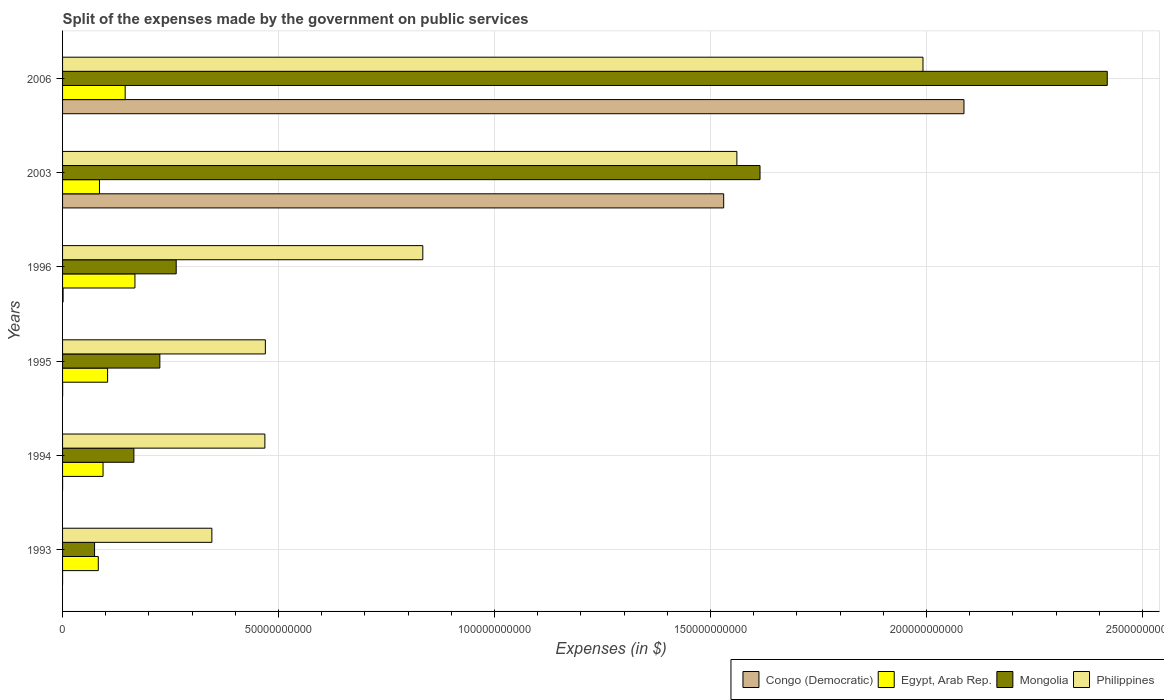Are the number of bars per tick equal to the number of legend labels?
Make the answer very short. Yes. How many bars are there on the 1st tick from the bottom?
Offer a terse response. 4. What is the expenses made by the government on public services in Mongolia in 2006?
Keep it short and to the point. 2.42e+11. Across all years, what is the maximum expenses made by the government on public services in Philippines?
Offer a terse response. 1.99e+11. Across all years, what is the minimum expenses made by the government on public services in Philippines?
Offer a terse response. 3.46e+1. In which year was the expenses made by the government on public services in Egypt, Arab Rep. minimum?
Your answer should be very brief. 1993. What is the total expenses made by the government on public services in Congo (Democratic) in the graph?
Make the answer very short. 3.62e+11. What is the difference between the expenses made by the government on public services in Congo (Democratic) in 1994 and that in 2003?
Ensure brevity in your answer.  -1.53e+11. What is the difference between the expenses made by the government on public services in Philippines in 1995 and the expenses made by the government on public services in Egypt, Arab Rep. in 2003?
Make the answer very short. 3.84e+1. What is the average expenses made by the government on public services in Egypt, Arab Rep. per year?
Give a very brief answer. 1.13e+1. In the year 2003, what is the difference between the expenses made by the government on public services in Philippines and expenses made by the government on public services in Egypt, Arab Rep.?
Ensure brevity in your answer.  1.48e+11. In how many years, is the expenses made by the government on public services in Mongolia greater than 80000000000 $?
Provide a succinct answer. 2. What is the ratio of the expenses made by the government on public services in Congo (Democratic) in 2003 to that in 2006?
Offer a very short reply. 0.73. Is the expenses made by the government on public services in Egypt, Arab Rep. in 1995 less than that in 2003?
Ensure brevity in your answer.  No. What is the difference between the highest and the second highest expenses made by the government on public services in Congo (Democratic)?
Your answer should be very brief. 5.56e+1. What is the difference between the highest and the lowest expenses made by the government on public services in Philippines?
Provide a short and direct response. 1.65e+11. In how many years, is the expenses made by the government on public services in Congo (Democratic) greater than the average expenses made by the government on public services in Congo (Democratic) taken over all years?
Your answer should be very brief. 2. Is the sum of the expenses made by the government on public services in Philippines in 1993 and 1994 greater than the maximum expenses made by the government on public services in Egypt, Arab Rep. across all years?
Your response must be concise. Yes. What does the 3rd bar from the bottom in 1994 represents?
Offer a very short reply. Mongolia. How many bars are there?
Offer a very short reply. 24. What is the difference between two consecutive major ticks on the X-axis?
Offer a very short reply. 5.00e+1. Are the values on the major ticks of X-axis written in scientific E-notation?
Your answer should be very brief. No. How many legend labels are there?
Provide a short and direct response. 4. How are the legend labels stacked?
Keep it short and to the point. Horizontal. What is the title of the graph?
Your answer should be compact. Split of the expenses made by the government on public services. What is the label or title of the X-axis?
Make the answer very short. Expenses (in $). What is the label or title of the Y-axis?
Give a very brief answer. Years. What is the Expenses (in $) of Congo (Democratic) in 1993?
Keep it short and to the point. 3.19e+04. What is the Expenses (in $) in Egypt, Arab Rep. in 1993?
Give a very brief answer. 8.27e+09. What is the Expenses (in $) in Mongolia in 1993?
Keep it short and to the point. 7.41e+09. What is the Expenses (in $) in Philippines in 1993?
Make the answer very short. 3.46e+1. What is the Expenses (in $) of Congo (Democratic) in 1994?
Your answer should be compact. 1.49e+06. What is the Expenses (in $) in Egypt, Arab Rep. in 1994?
Your response must be concise. 9.37e+09. What is the Expenses (in $) in Mongolia in 1994?
Your answer should be very brief. 1.65e+1. What is the Expenses (in $) in Philippines in 1994?
Provide a short and direct response. 4.68e+1. What is the Expenses (in $) in Congo (Democratic) in 1995?
Your answer should be compact. 1.21e+07. What is the Expenses (in $) of Egypt, Arab Rep. in 1995?
Give a very brief answer. 1.04e+1. What is the Expenses (in $) in Mongolia in 1995?
Provide a short and direct response. 2.25e+1. What is the Expenses (in $) in Philippines in 1995?
Provide a short and direct response. 4.70e+1. What is the Expenses (in $) of Congo (Democratic) in 1996?
Make the answer very short. 1.22e+08. What is the Expenses (in $) in Egypt, Arab Rep. in 1996?
Your response must be concise. 1.68e+1. What is the Expenses (in $) of Mongolia in 1996?
Offer a terse response. 2.63e+1. What is the Expenses (in $) in Philippines in 1996?
Provide a succinct answer. 8.34e+1. What is the Expenses (in $) in Congo (Democratic) in 2003?
Keep it short and to the point. 1.53e+11. What is the Expenses (in $) in Egypt, Arab Rep. in 2003?
Ensure brevity in your answer.  8.54e+09. What is the Expenses (in $) of Mongolia in 2003?
Give a very brief answer. 1.61e+11. What is the Expenses (in $) in Philippines in 2003?
Keep it short and to the point. 1.56e+11. What is the Expenses (in $) of Congo (Democratic) in 2006?
Provide a short and direct response. 2.09e+11. What is the Expenses (in $) in Egypt, Arab Rep. in 2006?
Your response must be concise. 1.45e+1. What is the Expenses (in $) of Mongolia in 2006?
Offer a very short reply. 2.42e+11. What is the Expenses (in $) of Philippines in 2006?
Your response must be concise. 1.99e+11. Across all years, what is the maximum Expenses (in $) of Congo (Democratic)?
Your response must be concise. 2.09e+11. Across all years, what is the maximum Expenses (in $) in Egypt, Arab Rep.?
Provide a succinct answer. 1.68e+1. Across all years, what is the maximum Expenses (in $) in Mongolia?
Offer a terse response. 2.42e+11. Across all years, what is the maximum Expenses (in $) in Philippines?
Offer a terse response. 1.99e+11. Across all years, what is the minimum Expenses (in $) in Congo (Democratic)?
Your answer should be compact. 3.19e+04. Across all years, what is the minimum Expenses (in $) of Egypt, Arab Rep.?
Offer a terse response. 8.27e+09. Across all years, what is the minimum Expenses (in $) of Mongolia?
Your answer should be very brief. 7.41e+09. Across all years, what is the minimum Expenses (in $) in Philippines?
Make the answer very short. 3.46e+1. What is the total Expenses (in $) of Congo (Democratic) in the graph?
Provide a succinct answer. 3.62e+11. What is the total Expenses (in $) of Egypt, Arab Rep. in the graph?
Ensure brevity in your answer.  6.79e+1. What is the total Expenses (in $) in Mongolia in the graph?
Your answer should be compact. 4.76e+11. What is the total Expenses (in $) in Philippines in the graph?
Your answer should be very brief. 5.67e+11. What is the difference between the Expenses (in $) in Congo (Democratic) in 1993 and that in 1994?
Offer a very short reply. -1.46e+06. What is the difference between the Expenses (in $) in Egypt, Arab Rep. in 1993 and that in 1994?
Your answer should be compact. -1.10e+09. What is the difference between the Expenses (in $) of Mongolia in 1993 and that in 1994?
Offer a very short reply. -9.11e+09. What is the difference between the Expenses (in $) in Philippines in 1993 and that in 1994?
Your response must be concise. -1.23e+1. What is the difference between the Expenses (in $) of Congo (Democratic) in 1993 and that in 1995?
Provide a short and direct response. -1.20e+07. What is the difference between the Expenses (in $) of Egypt, Arab Rep. in 1993 and that in 1995?
Ensure brevity in your answer.  -2.15e+09. What is the difference between the Expenses (in $) of Mongolia in 1993 and that in 1995?
Provide a succinct answer. -1.51e+1. What is the difference between the Expenses (in $) of Philippines in 1993 and that in 1995?
Ensure brevity in your answer.  -1.24e+1. What is the difference between the Expenses (in $) of Congo (Democratic) in 1993 and that in 1996?
Ensure brevity in your answer.  -1.22e+08. What is the difference between the Expenses (in $) in Egypt, Arab Rep. in 1993 and that in 1996?
Provide a succinct answer. -8.48e+09. What is the difference between the Expenses (in $) in Mongolia in 1993 and that in 1996?
Offer a very short reply. -1.89e+1. What is the difference between the Expenses (in $) in Philippines in 1993 and that in 1996?
Provide a succinct answer. -4.88e+1. What is the difference between the Expenses (in $) in Congo (Democratic) in 1993 and that in 2003?
Offer a terse response. -1.53e+11. What is the difference between the Expenses (in $) of Egypt, Arab Rep. in 1993 and that in 2003?
Provide a short and direct response. -2.70e+08. What is the difference between the Expenses (in $) of Mongolia in 1993 and that in 2003?
Your response must be concise. -1.54e+11. What is the difference between the Expenses (in $) in Philippines in 1993 and that in 2003?
Your response must be concise. -1.22e+11. What is the difference between the Expenses (in $) of Congo (Democratic) in 1993 and that in 2006?
Offer a very short reply. -2.09e+11. What is the difference between the Expenses (in $) of Egypt, Arab Rep. in 1993 and that in 2006?
Keep it short and to the point. -6.22e+09. What is the difference between the Expenses (in $) of Mongolia in 1993 and that in 2006?
Your response must be concise. -2.34e+11. What is the difference between the Expenses (in $) of Philippines in 1993 and that in 2006?
Offer a terse response. -1.65e+11. What is the difference between the Expenses (in $) in Congo (Democratic) in 1994 and that in 1995?
Provide a short and direct response. -1.06e+07. What is the difference between the Expenses (in $) in Egypt, Arab Rep. in 1994 and that in 1995?
Your answer should be compact. -1.05e+09. What is the difference between the Expenses (in $) in Mongolia in 1994 and that in 1995?
Offer a very short reply. -6.00e+09. What is the difference between the Expenses (in $) of Philippines in 1994 and that in 1995?
Offer a very short reply. -1.13e+08. What is the difference between the Expenses (in $) in Congo (Democratic) in 1994 and that in 1996?
Provide a succinct answer. -1.21e+08. What is the difference between the Expenses (in $) of Egypt, Arab Rep. in 1994 and that in 1996?
Give a very brief answer. -7.38e+09. What is the difference between the Expenses (in $) in Mongolia in 1994 and that in 1996?
Ensure brevity in your answer.  -9.80e+09. What is the difference between the Expenses (in $) of Philippines in 1994 and that in 1996?
Provide a short and direct response. -3.66e+1. What is the difference between the Expenses (in $) in Congo (Democratic) in 1994 and that in 2003?
Give a very brief answer. -1.53e+11. What is the difference between the Expenses (in $) in Egypt, Arab Rep. in 1994 and that in 2003?
Keep it short and to the point. 8.29e+08. What is the difference between the Expenses (in $) of Mongolia in 1994 and that in 2003?
Keep it short and to the point. -1.45e+11. What is the difference between the Expenses (in $) in Philippines in 1994 and that in 2003?
Your response must be concise. -1.09e+11. What is the difference between the Expenses (in $) of Congo (Democratic) in 1994 and that in 2006?
Provide a succinct answer. -2.09e+11. What is the difference between the Expenses (in $) of Egypt, Arab Rep. in 1994 and that in 2006?
Provide a short and direct response. -5.12e+09. What is the difference between the Expenses (in $) in Mongolia in 1994 and that in 2006?
Your answer should be very brief. -2.25e+11. What is the difference between the Expenses (in $) in Philippines in 1994 and that in 2006?
Your response must be concise. -1.52e+11. What is the difference between the Expenses (in $) of Congo (Democratic) in 1995 and that in 1996?
Make the answer very short. -1.10e+08. What is the difference between the Expenses (in $) in Egypt, Arab Rep. in 1995 and that in 1996?
Your answer should be very brief. -6.33e+09. What is the difference between the Expenses (in $) in Mongolia in 1995 and that in 1996?
Your response must be concise. -3.79e+09. What is the difference between the Expenses (in $) in Philippines in 1995 and that in 1996?
Offer a terse response. -3.65e+1. What is the difference between the Expenses (in $) of Congo (Democratic) in 1995 and that in 2003?
Provide a short and direct response. -1.53e+11. What is the difference between the Expenses (in $) of Egypt, Arab Rep. in 1995 and that in 2003?
Your answer should be compact. 1.88e+09. What is the difference between the Expenses (in $) in Mongolia in 1995 and that in 2003?
Make the answer very short. -1.39e+11. What is the difference between the Expenses (in $) in Philippines in 1995 and that in 2003?
Ensure brevity in your answer.  -1.09e+11. What is the difference between the Expenses (in $) of Congo (Democratic) in 1995 and that in 2006?
Provide a succinct answer. -2.09e+11. What is the difference between the Expenses (in $) in Egypt, Arab Rep. in 1995 and that in 2006?
Make the answer very short. -4.07e+09. What is the difference between the Expenses (in $) in Mongolia in 1995 and that in 2006?
Give a very brief answer. -2.19e+11. What is the difference between the Expenses (in $) of Philippines in 1995 and that in 2006?
Keep it short and to the point. -1.52e+11. What is the difference between the Expenses (in $) of Congo (Democratic) in 1996 and that in 2003?
Your answer should be very brief. -1.53e+11. What is the difference between the Expenses (in $) of Egypt, Arab Rep. in 1996 and that in 2003?
Make the answer very short. 8.21e+09. What is the difference between the Expenses (in $) in Mongolia in 1996 and that in 2003?
Offer a very short reply. -1.35e+11. What is the difference between the Expenses (in $) of Philippines in 1996 and that in 2003?
Provide a succinct answer. -7.27e+1. What is the difference between the Expenses (in $) of Congo (Democratic) in 1996 and that in 2006?
Keep it short and to the point. -2.09e+11. What is the difference between the Expenses (in $) of Egypt, Arab Rep. in 1996 and that in 2006?
Provide a succinct answer. 2.26e+09. What is the difference between the Expenses (in $) of Mongolia in 1996 and that in 2006?
Make the answer very short. -2.16e+11. What is the difference between the Expenses (in $) in Philippines in 1996 and that in 2006?
Keep it short and to the point. -1.16e+11. What is the difference between the Expenses (in $) in Congo (Democratic) in 2003 and that in 2006?
Keep it short and to the point. -5.56e+1. What is the difference between the Expenses (in $) in Egypt, Arab Rep. in 2003 and that in 2006?
Your response must be concise. -5.95e+09. What is the difference between the Expenses (in $) in Mongolia in 2003 and that in 2006?
Provide a succinct answer. -8.04e+1. What is the difference between the Expenses (in $) of Philippines in 2003 and that in 2006?
Provide a succinct answer. -4.31e+1. What is the difference between the Expenses (in $) of Congo (Democratic) in 1993 and the Expenses (in $) of Egypt, Arab Rep. in 1994?
Offer a terse response. -9.37e+09. What is the difference between the Expenses (in $) in Congo (Democratic) in 1993 and the Expenses (in $) in Mongolia in 1994?
Make the answer very short. -1.65e+1. What is the difference between the Expenses (in $) of Congo (Democratic) in 1993 and the Expenses (in $) of Philippines in 1994?
Keep it short and to the point. -4.68e+1. What is the difference between the Expenses (in $) in Egypt, Arab Rep. in 1993 and the Expenses (in $) in Mongolia in 1994?
Your response must be concise. -8.24e+09. What is the difference between the Expenses (in $) of Egypt, Arab Rep. in 1993 and the Expenses (in $) of Philippines in 1994?
Give a very brief answer. -3.86e+1. What is the difference between the Expenses (in $) in Mongolia in 1993 and the Expenses (in $) in Philippines in 1994?
Offer a very short reply. -3.94e+1. What is the difference between the Expenses (in $) in Congo (Democratic) in 1993 and the Expenses (in $) in Egypt, Arab Rep. in 1995?
Offer a very short reply. -1.04e+1. What is the difference between the Expenses (in $) in Congo (Democratic) in 1993 and the Expenses (in $) in Mongolia in 1995?
Your answer should be compact. -2.25e+1. What is the difference between the Expenses (in $) of Congo (Democratic) in 1993 and the Expenses (in $) of Philippines in 1995?
Offer a very short reply. -4.69e+1. What is the difference between the Expenses (in $) of Egypt, Arab Rep. in 1993 and the Expenses (in $) of Mongolia in 1995?
Your response must be concise. -1.42e+1. What is the difference between the Expenses (in $) in Egypt, Arab Rep. in 1993 and the Expenses (in $) in Philippines in 1995?
Your response must be concise. -3.87e+1. What is the difference between the Expenses (in $) in Mongolia in 1993 and the Expenses (in $) in Philippines in 1995?
Provide a short and direct response. -3.95e+1. What is the difference between the Expenses (in $) of Congo (Democratic) in 1993 and the Expenses (in $) of Egypt, Arab Rep. in 1996?
Offer a terse response. -1.68e+1. What is the difference between the Expenses (in $) of Congo (Democratic) in 1993 and the Expenses (in $) of Mongolia in 1996?
Provide a succinct answer. -2.63e+1. What is the difference between the Expenses (in $) in Congo (Democratic) in 1993 and the Expenses (in $) in Philippines in 1996?
Ensure brevity in your answer.  -8.34e+1. What is the difference between the Expenses (in $) of Egypt, Arab Rep. in 1993 and the Expenses (in $) of Mongolia in 1996?
Your answer should be compact. -1.80e+1. What is the difference between the Expenses (in $) of Egypt, Arab Rep. in 1993 and the Expenses (in $) of Philippines in 1996?
Provide a succinct answer. -7.51e+1. What is the difference between the Expenses (in $) of Mongolia in 1993 and the Expenses (in $) of Philippines in 1996?
Offer a very short reply. -7.60e+1. What is the difference between the Expenses (in $) of Congo (Democratic) in 1993 and the Expenses (in $) of Egypt, Arab Rep. in 2003?
Give a very brief answer. -8.54e+09. What is the difference between the Expenses (in $) of Congo (Democratic) in 1993 and the Expenses (in $) of Mongolia in 2003?
Your answer should be compact. -1.61e+11. What is the difference between the Expenses (in $) in Congo (Democratic) in 1993 and the Expenses (in $) in Philippines in 2003?
Your answer should be compact. -1.56e+11. What is the difference between the Expenses (in $) of Egypt, Arab Rep. in 1993 and the Expenses (in $) of Mongolia in 2003?
Give a very brief answer. -1.53e+11. What is the difference between the Expenses (in $) in Egypt, Arab Rep. in 1993 and the Expenses (in $) in Philippines in 2003?
Ensure brevity in your answer.  -1.48e+11. What is the difference between the Expenses (in $) of Mongolia in 1993 and the Expenses (in $) of Philippines in 2003?
Provide a succinct answer. -1.49e+11. What is the difference between the Expenses (in $) in Congo (Democratic) in 1993 and the Expenses (in $) in Egypt, Arab Rep. in 2006?
Provide a short and direct response. -1.45e+1. What is the difference between the Expenses (in $) of Congo (Democratic) in 1993 and the Expenses (in $) of Mongolia in 2006?
Make the answer very short. -2.42e+11. What is the difference between the Expenses (in $) in Congo (Democratic) in 1993 and the Expenses (in $) in Philippines in 2006?
Your answer should be compact. -1.99e+11. What is the difference between the Expenses (in $) in Egypt, Arab Rep. in 1993 and the Expenses (in $) in Mongolia in 2006?
Your answer should be compact. -2.34e+11. What is the difference between the Expenses (in $) in Egypt, Arab Rep. in 1993 and the Expenses (in $) in Philippines in 2006?
Your response must be concise. -1.91e+11. What is the difference between the Expenses (in $) of Mongolia in 1993 and the Expenses (in $) of Philippines in 2006?
Your response must be concise. -1.92e+11. What is the difference between the Expenses (in $) in Congo (Democratic) in 1994 and the Expenses (in $) in Egypt, Arab Rep. in 1995?
Keep it short and to the point. -1.04e+1. What is the difference between the Expenses (in $) in Congo (Democratic) in 1994 and the Expenses (in $) in Mongolia in 1995?
Offer a terse response. -2.25e+1. What is the difference between the Expenses (in $) in Congo (Democratic) in 1994 and the Expenses (in $) in Philippines in 1995?
Provide a succinct answer. -4.69e+1. What is the difference between the Expenses (in $) of Egypt, Arab Rep. in 1994 and the Expenses (in $) of Mongolia in 1995?
Offer a very short reply. -1.31e+1. What is the difference between the Expenses (in $) of Egypt, Arab Rep. in 1994 and the Expenses (in $) of Philippines in 1995?
Your answer should be compact. -3.76e+1. What is the difference between the Expenses (in $) of Mongolia in 1994 and the Expenses (in $) of Philippines in 1995?
Make the answer very short. -3.04e+1. What is the difference between the Expenses (in $) of Congo (Democratic) in 1994 and the Expenses (in $) of Egypt, Arab Rep. in 1996?
Give a very brief answer. -1.68e+1. What is the difference between the Expenses (in $) of Congo (Democratic) in 1994 and the Expenses (in $) of Mongolia in 1996?
Ensure brevity in your answer.  -2.63e+1. What is the difference between the Expenses (in $) of Congo (Democratic) in 1994 and the Expenses (in $) of Philippines in 1996?
Offer a very short reply. -8.34e+1. What is the difference between the Expenses (in $) of Egypt, Arab Rep. in 1994 and the Expenses (in $) of Mongolia in 1996?
Your response must be concise. -1.69e+1. What is the difference between the Expenses (in $) of Egypt, Arab Rep. in 1994 and the Expenses (in $) of Philippines in 1996?
Make the answer very short. -7.40e+1. What is the difference between the Expenses (in $) of Mongolia in 1994 and the Expenses (in $) of Philippines in 1996?
Make the answer very short. -6.69e+1. What is the difference between the Expenses (in $) in Congo (Democratic) in 1994 and the Expenses (in $) in Egypt, Arab Rep. in 2003?
Make the answer very short. -8.54e+09. What is the difference between the Expenses (in $) in Congo (Democratic) in 1994 and the Expenses (in $) in Mongolia in 2003?
Provide a short and direct response. -1.61e+11. What is the difference between the Expenses (in $) of Congo (Democratic) in 1994 and the Expenses (in $) of Philippines in 2003?
Provide a short and direct response. -1.56e+11. What is the difference between the Expenses (in $) of Egypt, Arab Rep. in 1994 and the Expenses (in $) of Mongolia in 2003?
Your response must be concise. -1.52e+11. What is the difference between the Expenses (in $) of Egypt, Arab Rep. in 1994 and the Expenses (in $) of Philippines in 2003?
Your answer should be very brief. -1.47e+11. What is the difference between the Expenses (in $) of Mongolia in 1994 and the Expenses (in $) of Philippines in 2003?
Keep it short and to the point. -1.40e+11. What is the difference between the Expenses (in $) in Congo (Democratic) in 1994 and the Expenses (in $) in Egypt, Arab Rep. in 2006?
Keep it short and to the point. -1.45e+1. What is the difference between the Expenses (in $) in Congo (Democratic) in 1994 and the Expenses (in $) in Mongolia in 2006?
Your answer should be very brief. -2.42e+11. What is the difference between the Expenses (in $) of Congo (Democratic) in 1994 and the Expenses (in $) of Philippines in 2006?
Your answer should be compact. -1.99e+11. What is the difference between the Expenses (in $) of Egypt, Arab Rep. in 1994 and the Expenses (in $) of Mongolia in 2006?
Make the answer very short. -2.32e+11. What is the difference between the Expenses (in $) of Egypt, Arab Rep. in 1994 and the Expenses (in $) of Philippines in 2006?
Provide a succinct answer. -1.90e+11. What is the difference between the Expenses (in $) in Mongolia in 1994 and the Expenses (in $) in Philippines in 2006?
Provide a short and direct response. -1.83e+11. What is the difference between the Expenses (in $) in Congo (Democratic) in 1995 and the Expenses (in $) in Egypt, Arab Rep. in 1996?
Keep it short and to the point. -1.67e+1. What is the difference between the Expenses (in $) in Congo (Democratic) in 1995 and the Expenses (in $) in Mongolia in 1996?
Make the answer very short. -2.63e+1. What is the difference between the Expenses (in $) of Congo (Democratic) in 1995 and the Expenses (in $) of Philippines in 1996?
Provide a succinct answer. -8.34e+1. What is the difference between the Expenses (in $) of Egypt, Arab Rep. in 1995 and the Expenses (in $) of Mongolia in 1996?
Give a very brief answer. -1.59e+1. What is the difference between the Expenses (in $) in Egypt, Arab Rep. in 1995 and the Expenses (in $) in Philippines in 1996?
Give a very brief answer. -7.30e+1. What is the difference between the Expenses (in $) in Mongolia in 1995 and the Expenses (in $) in Philippines in 1996?
Your answer should be compact. -6.09e+1. What is the difference between the Expenses (in $) of Congo (Democratic) in 1995 and the Expenses (in $) of Egypt, Arab Rep. in 2003?
Provide a short and direct response. -8.53e+09. What is the difference between the Expenses (in $) of Congo (Democratic) in 1995 and the Expenses (in $) of Mongolia in 2003?
Keep it short and to the point. -1.61e+11. What is the difference between the Expenses (in $) of Congo (Democratic) in 1995 and the Expenses (in $) of Philippines in 2003?
Your answer should be compact. -1.56e+11. What is the difference between the Expenses (in $) of Egypt, Arab Rep. in 1995 and the Expenses (in $) of Mongolia in 2003?
Your response must be concise. -1.51e+11. What is the difference between the Expenses (in $) of Egypt, Arab Rep. in 1995 and the Expenses (in $) of Philippines in 2003?
Provide a succinct answer. -1.46e+11. What is the difference between the Expenses (in $) in Mongolia in 1995 and the Expenses (in $) in Philippines in 2003?
Offer a terse response. -1.34e+11. What is the difference between the Expenses (in $) in Congo (Democratic) in 1995 and the Expenses (in $) in Egypt, Arab Rep. in 2006?
Offer a terse response. -1.45e+1. What is the difference between the Expenses (in $) in Congo (Democratic) in 1995 and the Expenses (in $) in Mongolia in 2006?
Your answer should be compact. -2.42e+11. What is the difference between the Expenses (in $) of Congo (Democratic) in 1995 and the Expenses (in $) of Philippines in 2006?
Provide a succinct answer. -1.99e+11. What is the difference between the Expenses (in $) of Egypt, Arab Rep. in 1995 and the Expenses (in $) of Mongolia in 2006?
Provide a short and direct response. -2.31e+11. What is the difference between the Expenses (in $) in Egypt, Arab Rep. in 1995 and the Expenses (in $) in Philippines in 2006?
Ensure brevity in your answer.  -1.89e+11. What is the difference between the Expenses (in $) of Mongolia in 1995 and the Expenses (in $) of Philippines in 2006?
Ensure brevity in your answer.  -1.77e+11. What is the difference between the Expenses (in $) of Congo (Democratic) in 1996 and the Expenses (in $) of Egypt, Arab Rep. in 2003?
Your answer should be compact. -8.42e+09. What is the difference between the Expenses (in $) of Congo (Democratic) in 1996 and the Expenses (in $) of Mongolia in 2003?
Ensure brevity in your answer.  -1.61e+11. What is the difference between the Expenses (in $) of Congo (Democratic) in 1996 and the Expenses (in $) of Philippines in 2003?
Give a very brief answer. -1.56e+11. What is the difference between the Expenses (in $) of Egypt, Arab Rep. in 1996 and the Expenses (in $) of Mongolia in 2003?
Keep it short and to the point. -1.45e+11. What is the difference between the Expenses (in $) of Egypt, Arab Rep. in 1996 and the Expenses (in $) of Philippines in 2003?
Your answer should be compact. -1.39e+11. What is the difference between the Expenses (in $) in Mongolia in 1996 and the Expenses (in $) in Philippines in 2003?
Provide a succinct answer. -1.30e+11. What is the difference between the Expenses (in $) in Congo (Democratic) in 1996 and the Expenses (in $) in Egypt, Arab Rep. in 2006?
Offer a terse response. -1.44e+1. What is the difference between the Expenses (in $) in Congo (Democratic) in 1996 and the Expenses (in $) in Mongolia in 2006?
Provide a short and direct response. -2.42e+11. What is the difference between the Expenses (in $) of Congo (Democratic) in 1996 and the Expenses (in $) of Philippines in 2006?
Make the answer very short. -1.99e+11. What is the difference between the Expenses (in $) of Egypt, Arab Rep. in 1996 and the Expenses (in $) of Mongolia in 2006?
Your answer should be very brief. -2.25e+11. What is the difference between the Expenses (in $) in Egypt, Arab Rep. in 1996 and the Expenses (in $) in Philippines in 2006?
Provide a succinct answer. -1.82e+11. What is the difference between the Expenses (in $) of Mongolia in 1996 and the Expenses (in $) of Philippines in 2006?
Provide a short and direct response. -1.73e+11. What is the difference between the Expenses (in $) in Congo (Democratic) in 2003 and the Expenses (in $) in Egypt, Arab Rep. in 2006?
Your answer should be very brief. 1.39e+11. What is the difference between the Expenses (in $) of Congo (Democratic) in 2003 and the Expenses (in $) of Mongolia in 2006?
Keep it short and to the point. -8.88e+1. What is the difference between the Expenses (in $) of Congo (Democratic) in 2003 and the Expenses (in $) of Philippines in 2006?
Provide a short and direct response. -4.61e+1. What is the difference between the Expenses (in $) of Egypt, Arab Rep. in 2003 and the Expenses (in $) of Mongolia in 2006?
Offer a terse response. -2.33e+11. What is the difference between the Expenses (in $) in Egypt, Arab Rep. in 2003 and the Expenses (in $) in Philippines in 2006?
Your response must be concise. -1.91e+11. What is the difference between the Expenses (in $) in Mongolia in 2003 and the Expenses (in $) in Philippines in 2006?
Offer a terse response. -3.77e+1. What is the average Expenses (in $) in Congo (Democratic) per year?
Provide a short and direct response. 6.03e+1. What is the average Expenses (in $) in Egypt, Arab Rep. per year?
Your answer should be compact. 1.13e+1. What is the average Expenses (in $) of Mongolia per year?
Make the answer very short. 7.93e+1. What is the average Expenses (in $) in Philippines per year?
Provide a succinct answer. 9.45e+1. In the year 1993, what is the difference between the Expenses (in $) in Congo (Democratic) and Expenses (in $) in Egypt, Arab Rep.?
Provide a succinct answer. -8.27e+09. In the year 1993, what is the difference between the Expenses (in $) of Congo (Democratic) and Expenses (in $) of Mongolia?
Your answer should be compact. -7.41e+09. In the year 1993, what is the difference between the Expenses (in $) of Congo (Democratic) and Expenses (in $) of Philippines?
Offer a terse response. -3.46e+1. In the year 1993, what is the difference between the Expenses (in $) of Egypt, Arab Rep. and Expenses (in $) of Mongolia?
Make the answer very short. 8.65e+08. In the year 1993, what is the difference between the Expenses (in $) of Egypt, Arab Rep. and Expenses (in $) of Philippines?
Ensure brevity in your answer.  -2.63e+1. In the year 1993, what is the difference between the Expenses (in $) of Mongolia and Expenses (in $) of Philippines?
Ensure brevity in your answer.  -2.72e+1. In the year 1994, what is the difference between the Expenses (in $) in Congo (Democratic) and Expenses (in $) in Egypt, Arab Rep.?
Provide a short and direct response. -9.37e+09. In the year 1994, what is the difference between the Expenses (in $) of Congo (Democratic) and Expenses (in $) of Mongolia?
Ensure brevity in your answer.  -1.65e+1. In the year 1994, what is the difference between the Expenses (in $) in Congo (Democratic) and Expenses (in $) in Philippines?
Give a very brief answer. -4.68e+1. In the year 1994, what is the difference between the Expenses (in $) of Egypt, Arab Rep. and Expenses (in $) of Mongolia?
Offer a very short reply. -7.14e+09. In the year 1994, what is the difference between the Expenses (in $) of Egypt, Arab Rep. and Expenses (in $) of Philippines?
Make the answer very short. -3.75e+1. In the year 1994, what is the difference between the Expenses (in $) in Mongolia and Expenses (in $) in Philippines?
Offer a very short reply. -3.03e+1. In the year 1995, what is the difference between the Expenses (in $) of Congo (Democratic) and Expenses (in $) of Egypt, Arab Rep.?
Ensure brevity in your answer.  -1.04e+1. In the year 1995, what is the difference between the Expenses (in $) in Congo (Democratic) and Expenses (in $) in Mongolia?
Make the answer very short. -2.25e+1. In the year 1995, what is the difference between the Expenses (in $) in Congo (Democratic) and Expenses (in $) in Philippines?
Provide a short and direct response. -4.69e+1. In the year 1995, what is the difference between the Expenses (in $) in Egypt, Arab Rep. and Expenses (in $) in Mongolia?
Make the answer very short. -1.21e+1. In the year 1995, what is the difference between the Expenses (in $) of Egypt, Arab Rep. and Expenses (in $) of Philippines?
Provide a short and direct response. -3.65e+1. In the year 1995, what is the difference between the Expenses (in $) in Mongolia and Expenses (in $) in Philippines?
Provide a short and direct response. -2.44e+1. In the year 1996, what is the difference between the Expenses (in $) in Congo (Democratic) and Expenses (in $) in Egypt, Arab Rep.?
Provide a short and direct response. -1.66e+1. In the year 1996, what is the difference between the Expenses (in $) in Congo (Democratic) and Expenses (in $) in Mongolia?
Provide a short and direct response. -2.62e+1. In the year 1996, what is the difference between the Expenses (in $) of Congo (Democratic) and Expenses (in $) of Philippines?
Your answer should be compact. -8.33e+1. In the year 1996, what is the difference between the Expenses (in $) in Egypt, Arab Rep. and Expenses (in $) in Mongolia?
Your response must be concise. -9.55e+09. In the year 1996, what is the difference between the Expenses (in $) of Egypt, Arab Rep. and Expenses (in $) of Philippines?
Provide a succinct answer. -6.66e+1. In the year 1996, what is the difference between the Expenses (in $) of Mongolia and Expenses (in $) of Philippines?
Your answer should be compact. -5.71e+1. In the year 2003, what is the difference between the Expenses (in $) in Congo (Democratic) and Expenses (in $) in Egypt, Arab Rep.?
Provide a short and direct response. 1.45e+11. In the year 2003, what is the difference between the Expenses (in $) of Congo (Democratic) and Expenses (in $) of Mongolia?
Ensure brevity in your answer.  -8.41e+09. In the year 2003, what is the difference between the Expenses (in $) of Congo (Democratic) and Expenses (in $) of Philippines?
Offer a very short reply. -3.05e+09. In the year 2003, what is the difference between the Expenses (in $) in Egypt, Arab Rep. and Expenses (in $) in Mongolia?
Give a very brief answer. -1.53e+11. In the year 2003, what is the difference between the Expenses (in $) of Egypt, Arab Rep. and Expenses (in $) of Philippines?
Your answer should be compact. -1.48e+11. In the year 2003, what is the difference between the Expenses (in $) of Mongolia and Expenses (in $) of Philippines?
Offer a very short reply. 5.36e+09. In the year 2006, what is the difference between the Expenses (in $) of Congo (Democratic) and Expenses (in $) of Egypt, Arab Rep.?
Offer a terse response. 1.94e+11. In the year 2006, what is the difference between the Expenses (in $) of Congo (Democratic) and Expenses (in $) of Mongolia?
Your answer should be compact. -3.32e+1. In the year 2006, what is the difference between the Expenses (in $) in Congo (Democratic) and Expenses (in $) in Philippines?
Your answer should be compact. 9.49e+09. In the year 2006, what is the difference between the Expenses (in $) of Egypt, Arab Rep. and Expenses (in $) of Mongolia?
Offer a very short reply. -2.27e+11. In the year 2006, what is the difference between the Expenses (in $) in Egypt, Arab Rep. and Expenses (in $) in Philippines?
Give a very brief answer. -1.85e+11. In the year 2006, what is the difference between the Expenses (in $) in Mongolia and Expenses (in $) in Philippines?
Give a very brief answer. 4.27e+1. What is the ratio of the Expenses (in $) in Congo (Democratic) in 1993 to that in 1994?
Provide a short and direct response. 0.02. What is the ratio of the Expenses (in $) of Egypt, Arab Rep. in 1993 to that in 1994?
Give a very brief answer. 0.88. What is the ratio of the Expenses (in $) in Mongolia in 1993 to that in 1994?
Provide a succinct answer. 0.45. What is the ratio of the Expenses (in $) of Philippines in 1993 to that in 1994?
Offer a terse response. 0.74. What is the ratio of the Expenses (in $) of Congo (Democratic) in 1993 to that in 1995?
Make the answer very short. 0. What is the ratio of the Expenses (in $) in Egypt, Arab Rep. in 1993 to that in 1995?
Your answer should be very brief. 0.79. What is the ratio of the Expenses (in $) in Mongolia in 1993 to that in 1995?
Provide a short and direct response. 0.33. What is the ratio of the Expenses (in $) in Philippines in 1993 to that in 1995?
Offer a very short reply. 0.74. What is the ratio of the Expenses (in $) of Egypt, Arab Rep. in 1993 to that in 1996?
Make the answer very short. 0.49. What is the ratio of the Expenses (in $) in Mongolia in 1993 to that in 1996?
Provide a short and direct response. 0.28. What is the ratio of the Expenses (in $) of Philippines in 1993 to that in 1996?
Ensure brevity in your answer.  0.41. What is the ratio of the Expenses (in $) in Egypt, Arab Rep. in 1993 to that in 2003?
Offer a very short reply. 0.97. What is the ratio of the Expenses (in $) in Mongolia in 1993 to that in 2003?
Offer a very short reply. 0.05. What is the ratio of the Expenses (in $) in Philippines in 1993 to that in 2003?
Provide a short and direct response. 0.22. What is the ratio of the Expenses (in $) in Egypt, Arab Rep. in 1993 to that in 2006?
Offer a terse response. 0.57. What is the ratio of the Expenses (in $) of Mongolia in 1993 to that in 2006?
Your answer should be compact. 0.03. What is the ratio of the Expenses (in $) in Philippines in 1993 to that in 2006?
Provide a succinct answer. 0.17. What is the ratio of the Expenses (in $) in Congo (Democratic) in 1994 to that in 1995?
Offer a very short reply. 0.12. What is the ratio of the Expenses (in $) in Egypt, Arab Rep. in 1994 to that in 1995?
Make the answer very short. 0.9. What is the ratio of the Expenses (in $) of Mongolia in 1994 to that in 1995?
Your answer should be very brief. 0.73. What is the ratio of the Expenses (in $) of Philippines in 1994 to that in 1995?
Give a very brief answer. 1. What is the ratio of the Expenses (in $) of Congo (Democratic) in 1994 to that in 1996?
Provide a succinct answer. 0.01. What is the ratio of the Expenses (in $) in Egypt, Arab Rep. in 1994 to that in 1996?
Your answer should be very brief. 0.56. What is the ratio of the Expenses (in $) in Mongolia in 1994 to that in 1996?
Your answer should be compact. 0.63. What is the ratio of the Expenses (in $) of Philippines in 1994 to that in 1996?
Offer a terse response. 0.56. What is the ratio of the Expenses (in $) of Congo (Democratic) in 1994 to that in 2003?
Ensure brevity in your answer.  0. What is the ratio of the Expenses (in $) of Egypt, Arab Rep. in 1994 to that in 2003?
Make the answer very short. 1.1. What is the ratio of the Expenses (in $) in Mongolia in 1994 to that in 2003?
Provide a short and direct response. 0.1. What is the ratio of the Expenses (in $) of Egypt, Arab Rep. in 1994 to that in 2006?
Your response must be concise. 0.65. What is the ratio of the Expenses (in $) in Mongolia in 1994 to that in 2006?
Keep it short and to the point. 0.07. What is the ratio of the Expenses (in $) in Philippines in 1994 to that in 2006?
Provide a succinct answer. 0.24. What is the ratio of the Expenses (in $) of Congo (Democratic) in 1995 to that in 1996?
Offer a very short reply. 0.1. What is the ratio of the Expenses (in $) in Egypt, Arab Rep. in 1995 to that in 1996?
Provide a short and direct response. 0.62. What is the ratio of the Expenses (in $) of Mongolia in 1995 to that in 1996?
Your answer should be compact. 0.86. What is the ratio of the Expenses (in $) in Philippines in 1995 to that in 1996?
Provide a succinct answer. 0.56. What is the ratio of the Expenses (in $) of Congo (Democratic) in 1995 to that in 2003?
Provide a succinct answer. 0. What is the ratio of the Expenses (in $) of Egypt, Arab Rep. in 1995 to that in 2003?
Ensure brevity in your answer.  1.22. What is the ratio of the Expenses (in $) of Mongolia in 1995 to that in 2003?
Offer a very short reply. 0.14. What is the ratio of the Expenses (in $) in Philippines in 1995 to that in 2003?
Your answer should be compact. 0.3. What is the ratio of the Expenses (in $) of Egypt, Arab Rep. in 1995 to that in 2006?
Keep it short and to the point. 0.72. What is the ratio of the Expenses (in $) of Mongolia in 1995 to that in 2006?
Provide a succinct answer. 0.09. What is the ratio of the Expenses (in $) of Philippines in 1995 to that in 2006?
Your response must be concise. 0.24. What is the ratio of the Expenses (in $) of Congo (Democratic) in 1996 to that in 2003?
Provide a succinct answer. 0. What is the ratio of the Expenses (in $) in Egypt, Arab Rep. in 1996 to that in 2003?
Provide a short and direct response. 1.96. What is the ratio of the Expenses (in $) in Mongolia in 1996 to that in 2003?
Your answer should be compact. 0.16. What is the ratio of the Expenses (in $) of Philippines in 1996 to that in 2003?
Your response must be concise. 0.53. What is the ratio of the Expenses (in $) of Congo (Democratic) in 1996 to that in 2006?
Provide a short and direct response. 0. What is the ratio of the Expenses (in $) of Egypt, Arab Rep. in 1996 to that in 2006?
Your answer should be compact. 1.16. What is the ratio of the Expenses (in $) in Mongolia in 1996 to that in 2006?
Provide a short and direct response. 0.11. What is the ratio of the Expenses (in $) in Philippines in 1996 to that in 2006?
Your answer should be compact. 0.42. What is the ratio of the Expenses (in $) of Congo (Democratic) in 2003 to that in 2006?
Provide a short and direct response. 0.73. What is the ratio of the Expenses (in $) of Egypt, Arab Rep. in 2003 to that in 2006?
Keep it short and to the point. 0.59. What is the ratio of the Expenses (in $) of Mongolia in 2003 to that in 2006?
Your answer should be very brief. 0.67. What is the ratio of the Expenses (in $) of Philippines in 2003 to that in 2006?
Offer a terse response. 0.78. What is the difference between the highest and the second highest Expenses (in $) of Congo (Democratic)?
Your response must be concise. 5.56e+1. What is the difference between the highest and the second highest Expenses (in $) of Egypt, Arab Rep.?
Keep it short and to the point. 2.26e+09. What is the difference between the highest and the second highest Expenses (in $) in Mongolia?
Your answer should be very brief. 8.04e+1. What is the difference between the highest and the second highest Expenses (in $) of Philippines?
Keep it short and to the point. 4.31e+1. What is the difference between the highest and the lowest Expenses (in $) of Congo (Democratic)?
Ensure brevity in your answer.  2.09e+11. What is the difference between the highest and the lowest Expenses (in $) in Egypt, Arab Rep.?
Offer a very short reply. 8.48e+09. What is the difference between the highest and the lowest Expenses (in $) of Mongolia?
Ensure brevity in your answer.  2.34e+11. What is the difference between the highest and the lowest Expenses (in $) in Philippines?
Provide a short and direct response. 1.65e+11. 